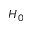<formula> <loc_0><loc_0><loc_500><loc_500>H _ { 0 }</formula> 